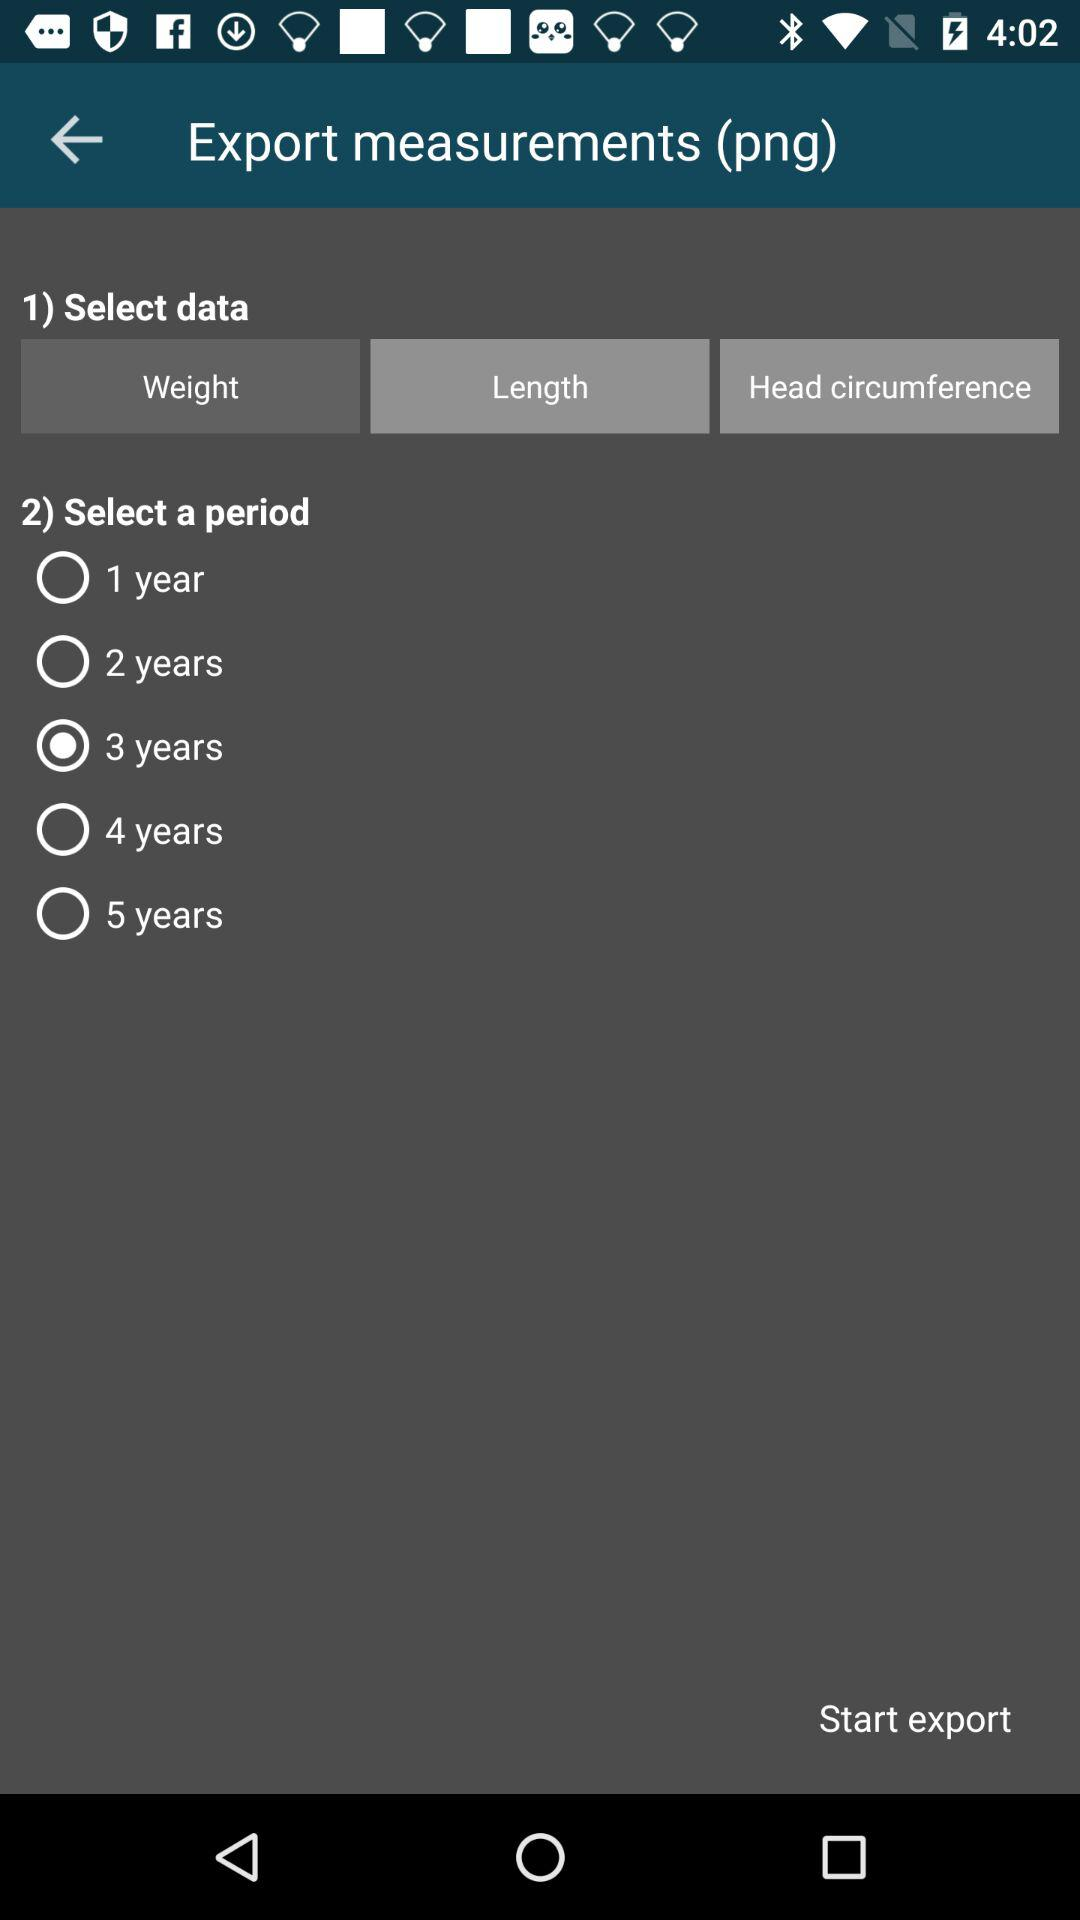How many years are available to select from?
Answer the question using a single word or phrase. 5 